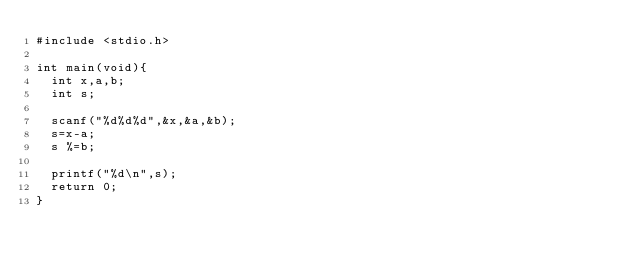<code> <loc_0><loc_0><loc_500><loc_500><_C_>#include <stdio.h>

int main(void){
	int x,a,b;
	int s;

	scanf("%d%d%d",&x,&a,&b);
	s=x-a;
	s %=b;

	printf("%d\n",s);
	return 0;
}
</code> 